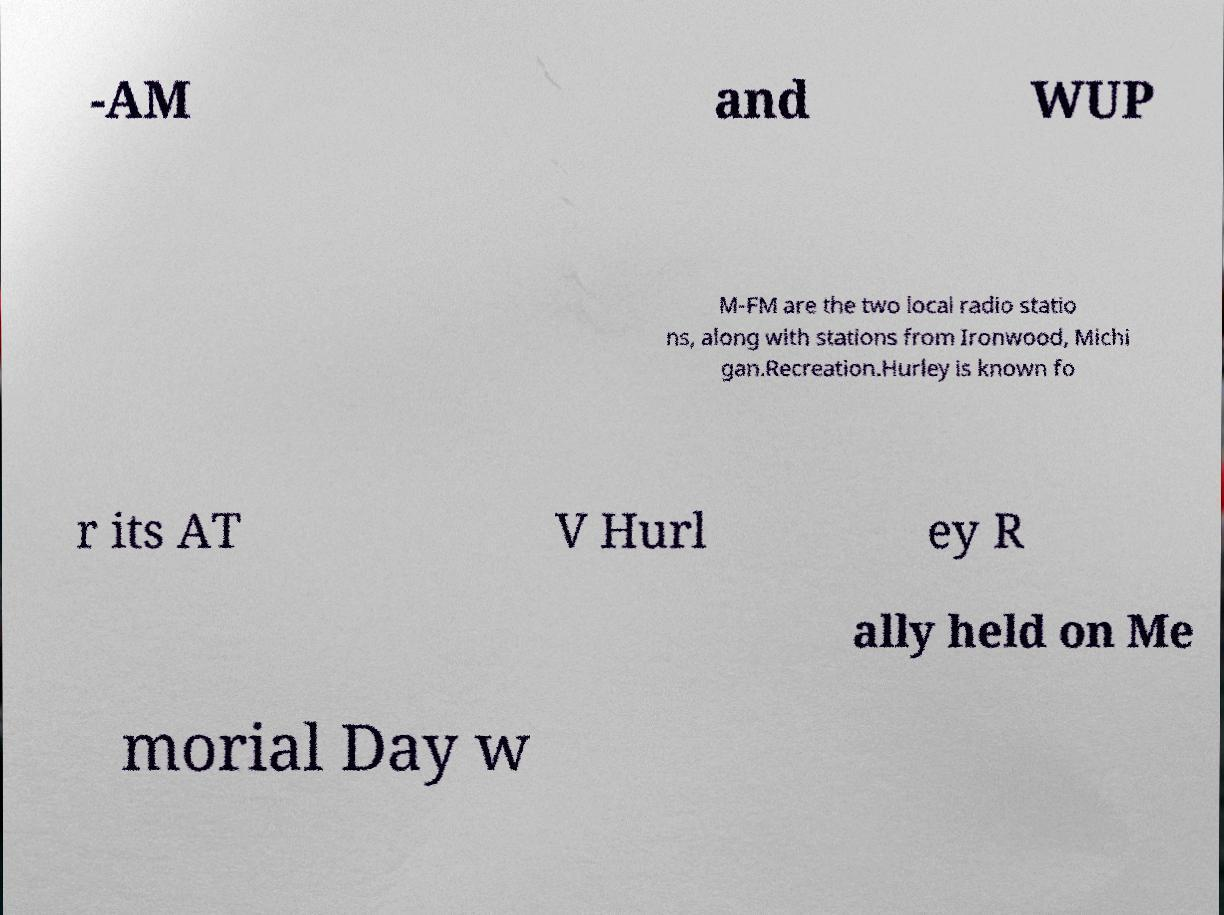Can you read and provide the text displayed in the image?This photo seems to have some interesting text. Can you extract and type it out for me? -AM and WUP M-FM are the two local radio statio ns, along with stations from Ironwood, Michi gan.Recreation.Hurley is known fo r its AT V Hurl ey R ally held on Me morial Day w 